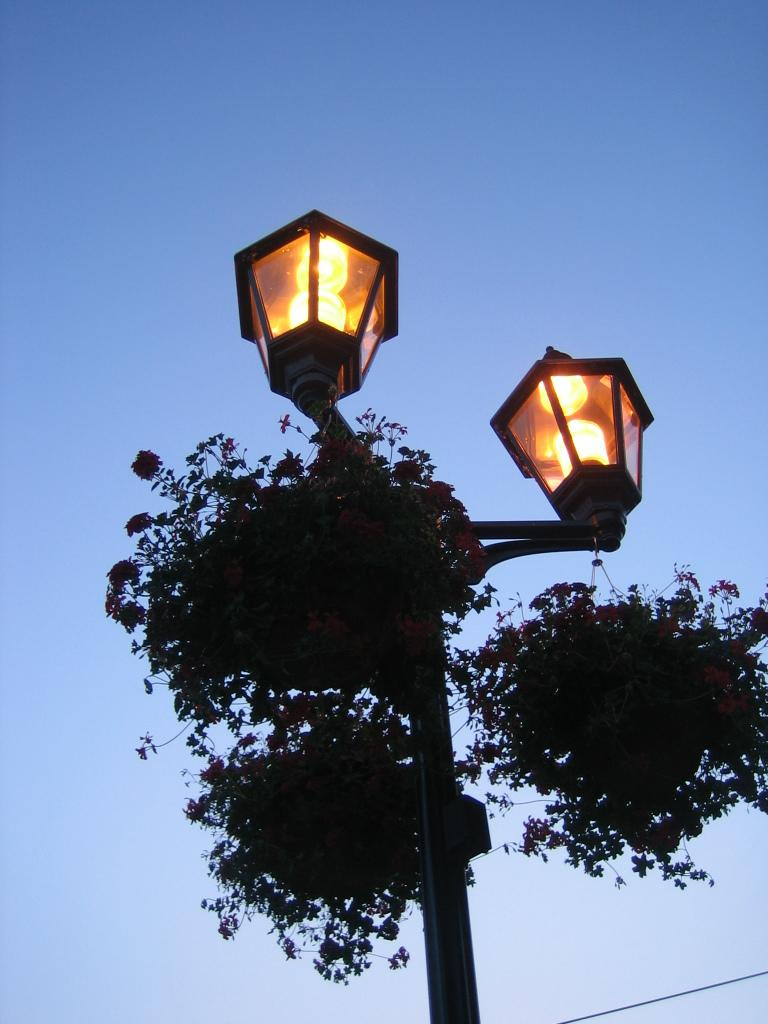What is attached to the pole in the image? There are lamps attached to the pole in the image. What can be found in the pots in the image? There are plants and flowers in the pots in the image. What is visible in the background of the image? There is a sky visible in the background of the image. Can you see a horse grazing in the background of the image? There is no horse present in the image; it only features a pole with lamps, pots with plants, and flowers. 